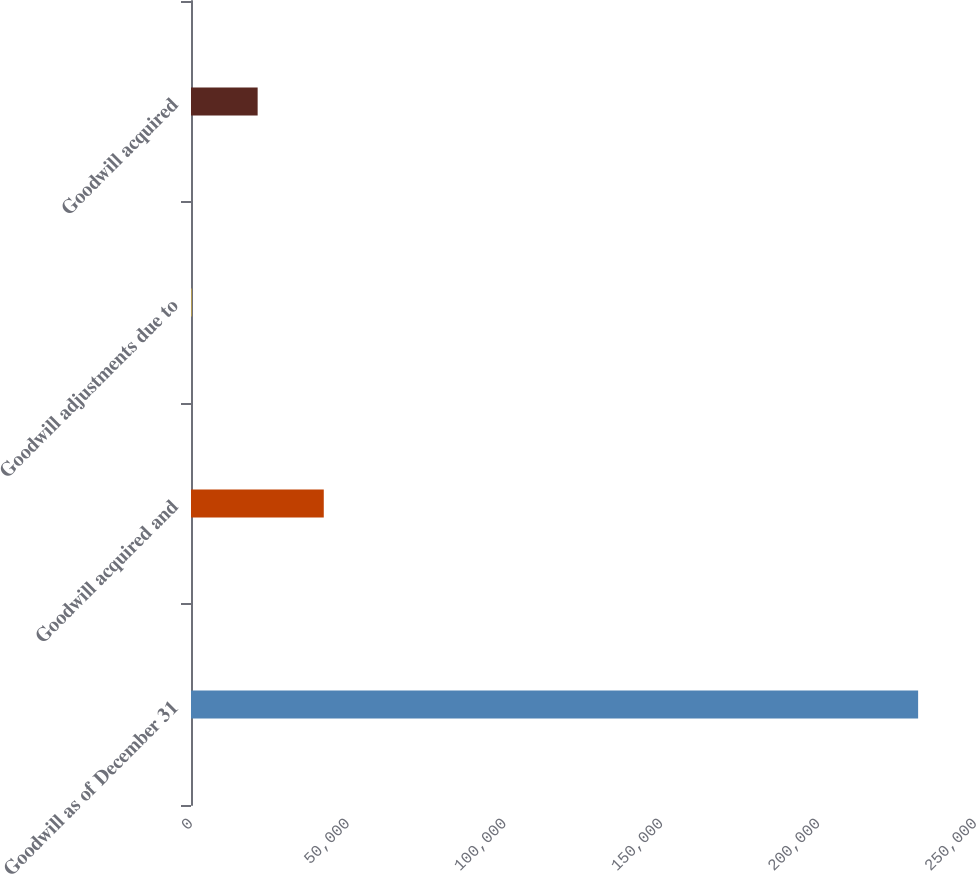Convert chart to OTSL. <chart><loc_0><loc_0><loc_500><loc_500><bar_chart><fcel>Goodwill as of December 31<fcel>Goodwill acquired and<fcel>Goodwill adjustments due to<fcel>Goodwill acquired<nl><fcel>231864<fcel>42337.4<fcel>167<fcel>21252.2<nl></chart> 